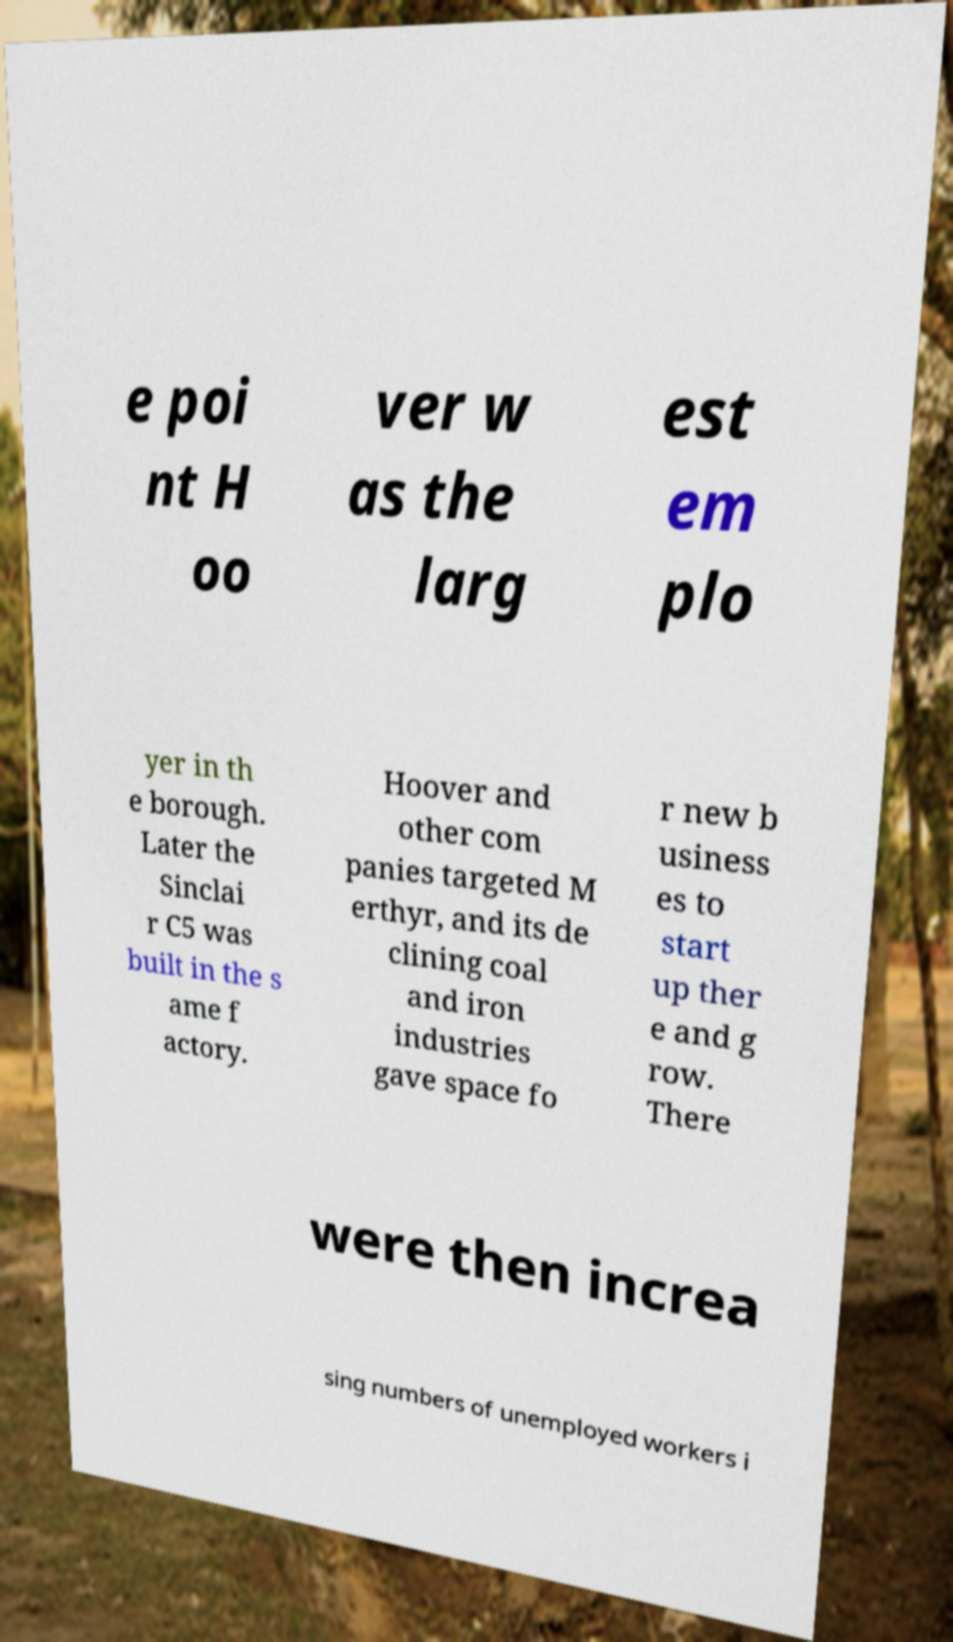There's text embedded in this image that I need extracted. Can you transcribe it verbatim? e poi nt H oo ver w as the larg est em plo yer in th e borough. Later the Sinclai r C5 was built in the s ame f actory. Hoover and other com panies targeted M erthyr, and its de clining coal and iron industries gave space fo r new b usiness es to start up ther e and g row. There were then increa sing numbers of unemployed workers i 